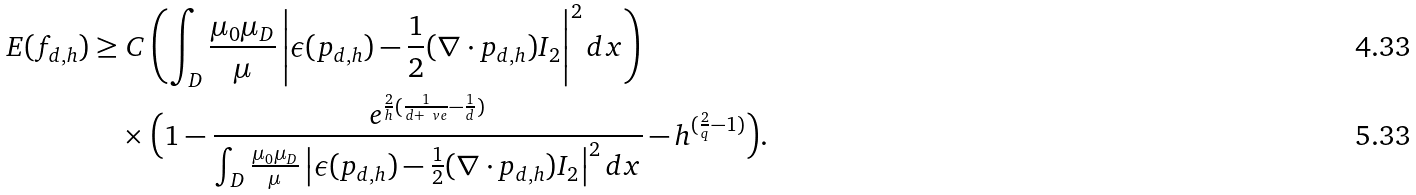<formula> <loc_0><loc_0><loc_500><loc_500>E ( f _ { d , h } ) & \geq C \left ( \int _ { D } \frac { \mu _ { 0 } \mu _ { D } } { \mu } \left | \epsilon ( p _ { d , h } ) - \frac { 1 } { 2 } ( \nabla \cdot p _ { d , h } ) I _ { 2 } \right | ^ { 2 } d x \right ) \\ & \quad \times \Big { ( } 1 - \frac { e ^ { \frac { 2 } { h } ( \frac { 1 } { d + \ v e } - \frac { 1 } { d } ) } } { \int _ { D } \frac { \mu _ { 0 } \mu _ { D } } { \mu } \left | \epsilon ( p _ { d , h } ) - \frac { 1 } { 2 } ( \nabla \cdot p _ { d , h } ) I _ { 2 } \right | ^ { 2 } d x } - h ^ { ( \frac { 2 } { q } - 1 ) } \Big { ) } .</formula> 